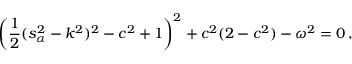Convert formula to latex. <formula><loc_0><loc_0><loc_500><loc_500>\left ( \frac { 1 } { 2 } ( s _ { \alpha } ^ { 2 } - k ^ { 2 } ) ^ { 2 } - c ^ { 2 } + 1 \right ) ^ { 2 } + c ^ { 2 } ( 2 - c ^ { 2 } ) - \omega ^ { 2 } = 0 \, ,</formula> 